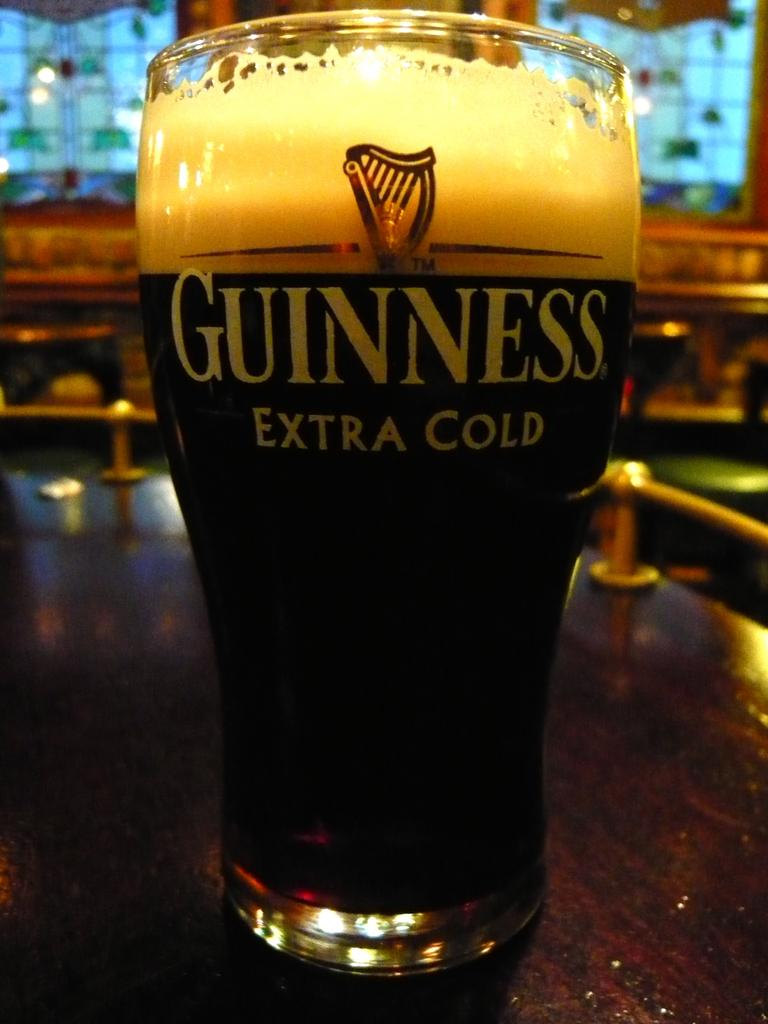<image>
Summarize the visual content of the image. A glass full of liquid is imprinted with "Guiness extra cold" 